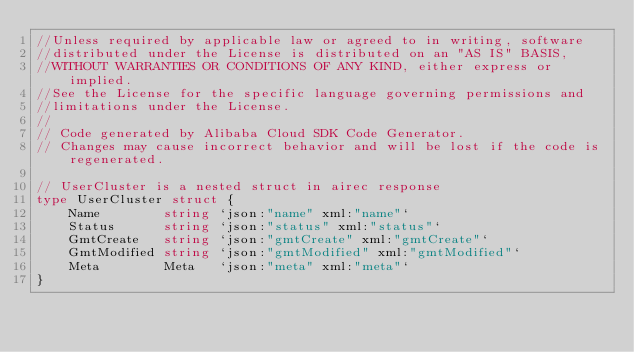<code> <loc_0><loc_0><loc_500><loc_500><_Go_>//Unless required by applicable law or agreed to in writing, software
//distributed under the License is distributed on an "AS IS" BASIS,
//WITHOUT WARRANTIES OR CONDITIONS OF ANY KIND, either express or implied.
//See the License for the specific language governing permissions and
//limitations under the License.
//
// Code generated by Alibaba Cloud SDK Code Generator.
// Changes may cause incorrect behavior and will be lost if the code is regenerated.

// UserCluster is a nested struct in airec response
type UserCluster struct {
	Name        string `json:"name" xml:"name"`
	Status      string `json:"status" xml:"status"`
	GmtCreate   string `json:"gmtCreate" xml:"gmtCreate"`
	GmtModified string `json:"gmtModified" xml:"gmtModified"`
	Meta        Meta   `json:"meta" xml:"meta"`
}
</code> 